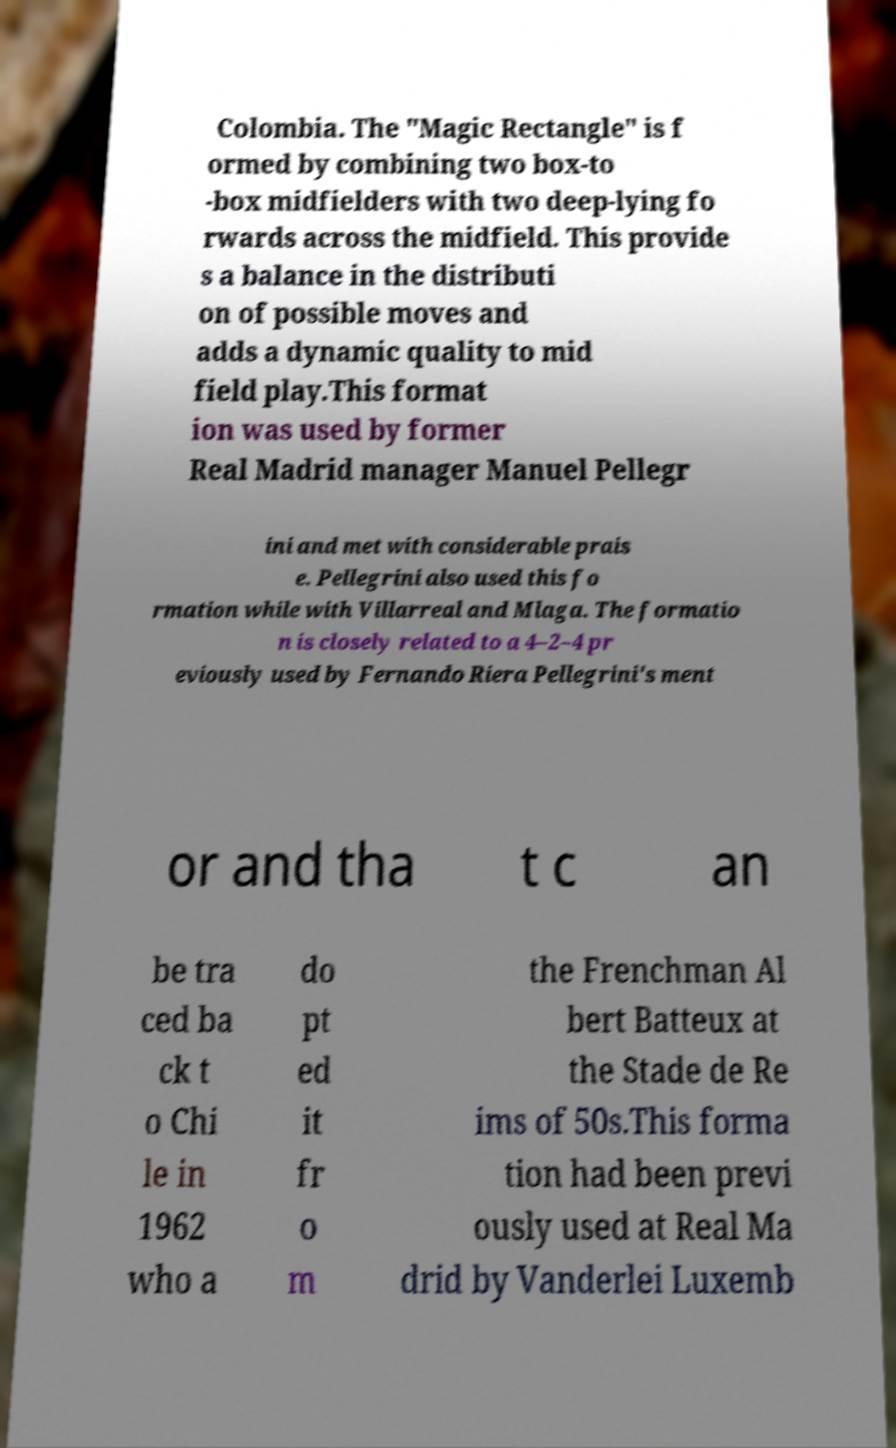Please read and relay the text visible in this image. What does it say? Colombia. The "Magic Rectangle" is f ormed by combining two box-to -box midfielders with two deep-lying fo rwards across the midfield. This provide s a balance in the distributi on of possible moves and adds a dynamic quality to mid field play.This format ion was used by former Real Madrid manager Manuel Pellegr ini and met with considerable prais e. Pellegrini also used this fo rmation while with Villarreal and Mlaga. The formatio n is closely related to a 4–2–4 pr eviously used by Fernando Riera Pellegrini's ment or and tha t c an be tra ced ba ck t o Chi le in 1962 who a do pt ed it fr o m the Frenchman Al bert Batteux at the Stade de Re ims of 50s.This forma tion had been previ ously used at Real Ma drid by Vanderlei Luxemb 